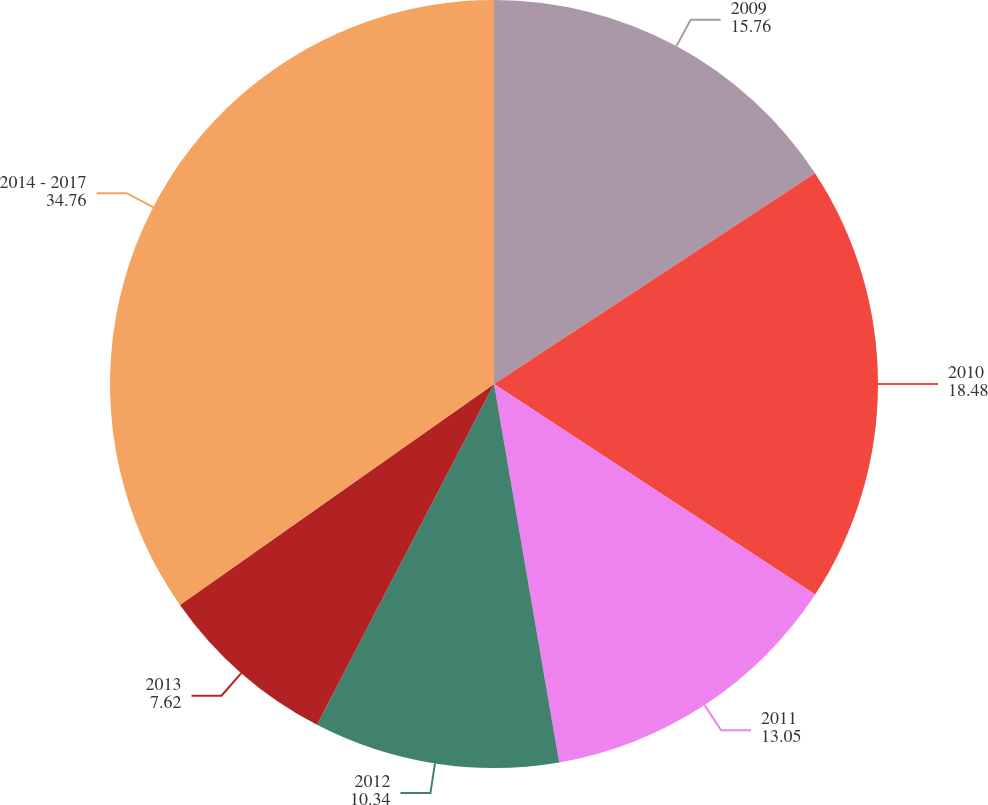<chart> <loc_0><loc_0><loc_500><loc_500><pie_chart><fcel>2009<fcel>2010<fcel>2011<fcel>2012<fcel>2013<fcel>2014 - 2017<nl><fcel>15.76%<fcel>18.48%<fcel>13.05%<fcel>10.34%<fcel>7.62%<fcel>34.76%<nl></chart> 